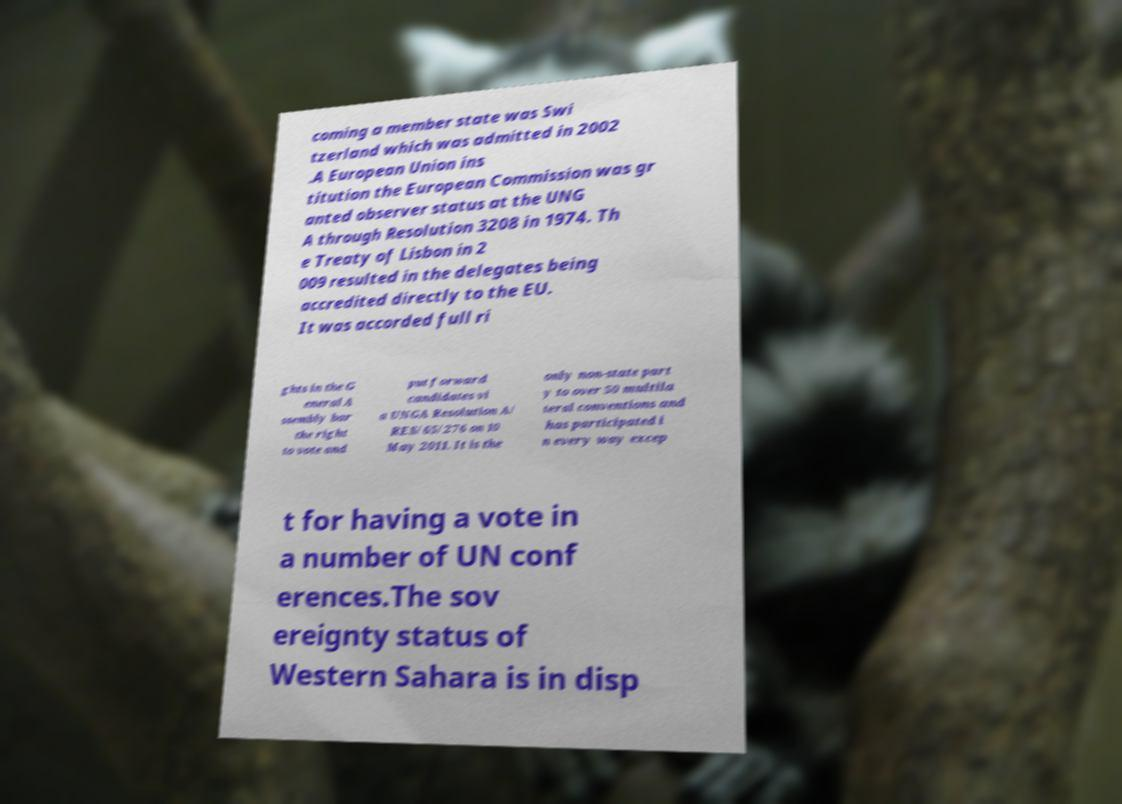I need the written content from this picture converted into text. Can you do that? coming a member state was Swi tzerland which was admitted in 2002 .A European Union ins titution the European Commission was gr anted observer status at the UNG A through Resolution 3208 in 1974. Th e Treaty of Lisbon in 2 009 resulted in the delegates being accredited directly to the EU. It was accorded full ri ghts in the G eneral A ssembly bar the right to vote and put forward candidates vi a UNGA Resolution A/ RES/65/276 on 10 May 2011. It is the only non-state part y to over 50 multila teral conventions and has participated i n every way excep t for having a vote in a number of UN conf erences.The sov ereignty status of Western Sahara is in disp 